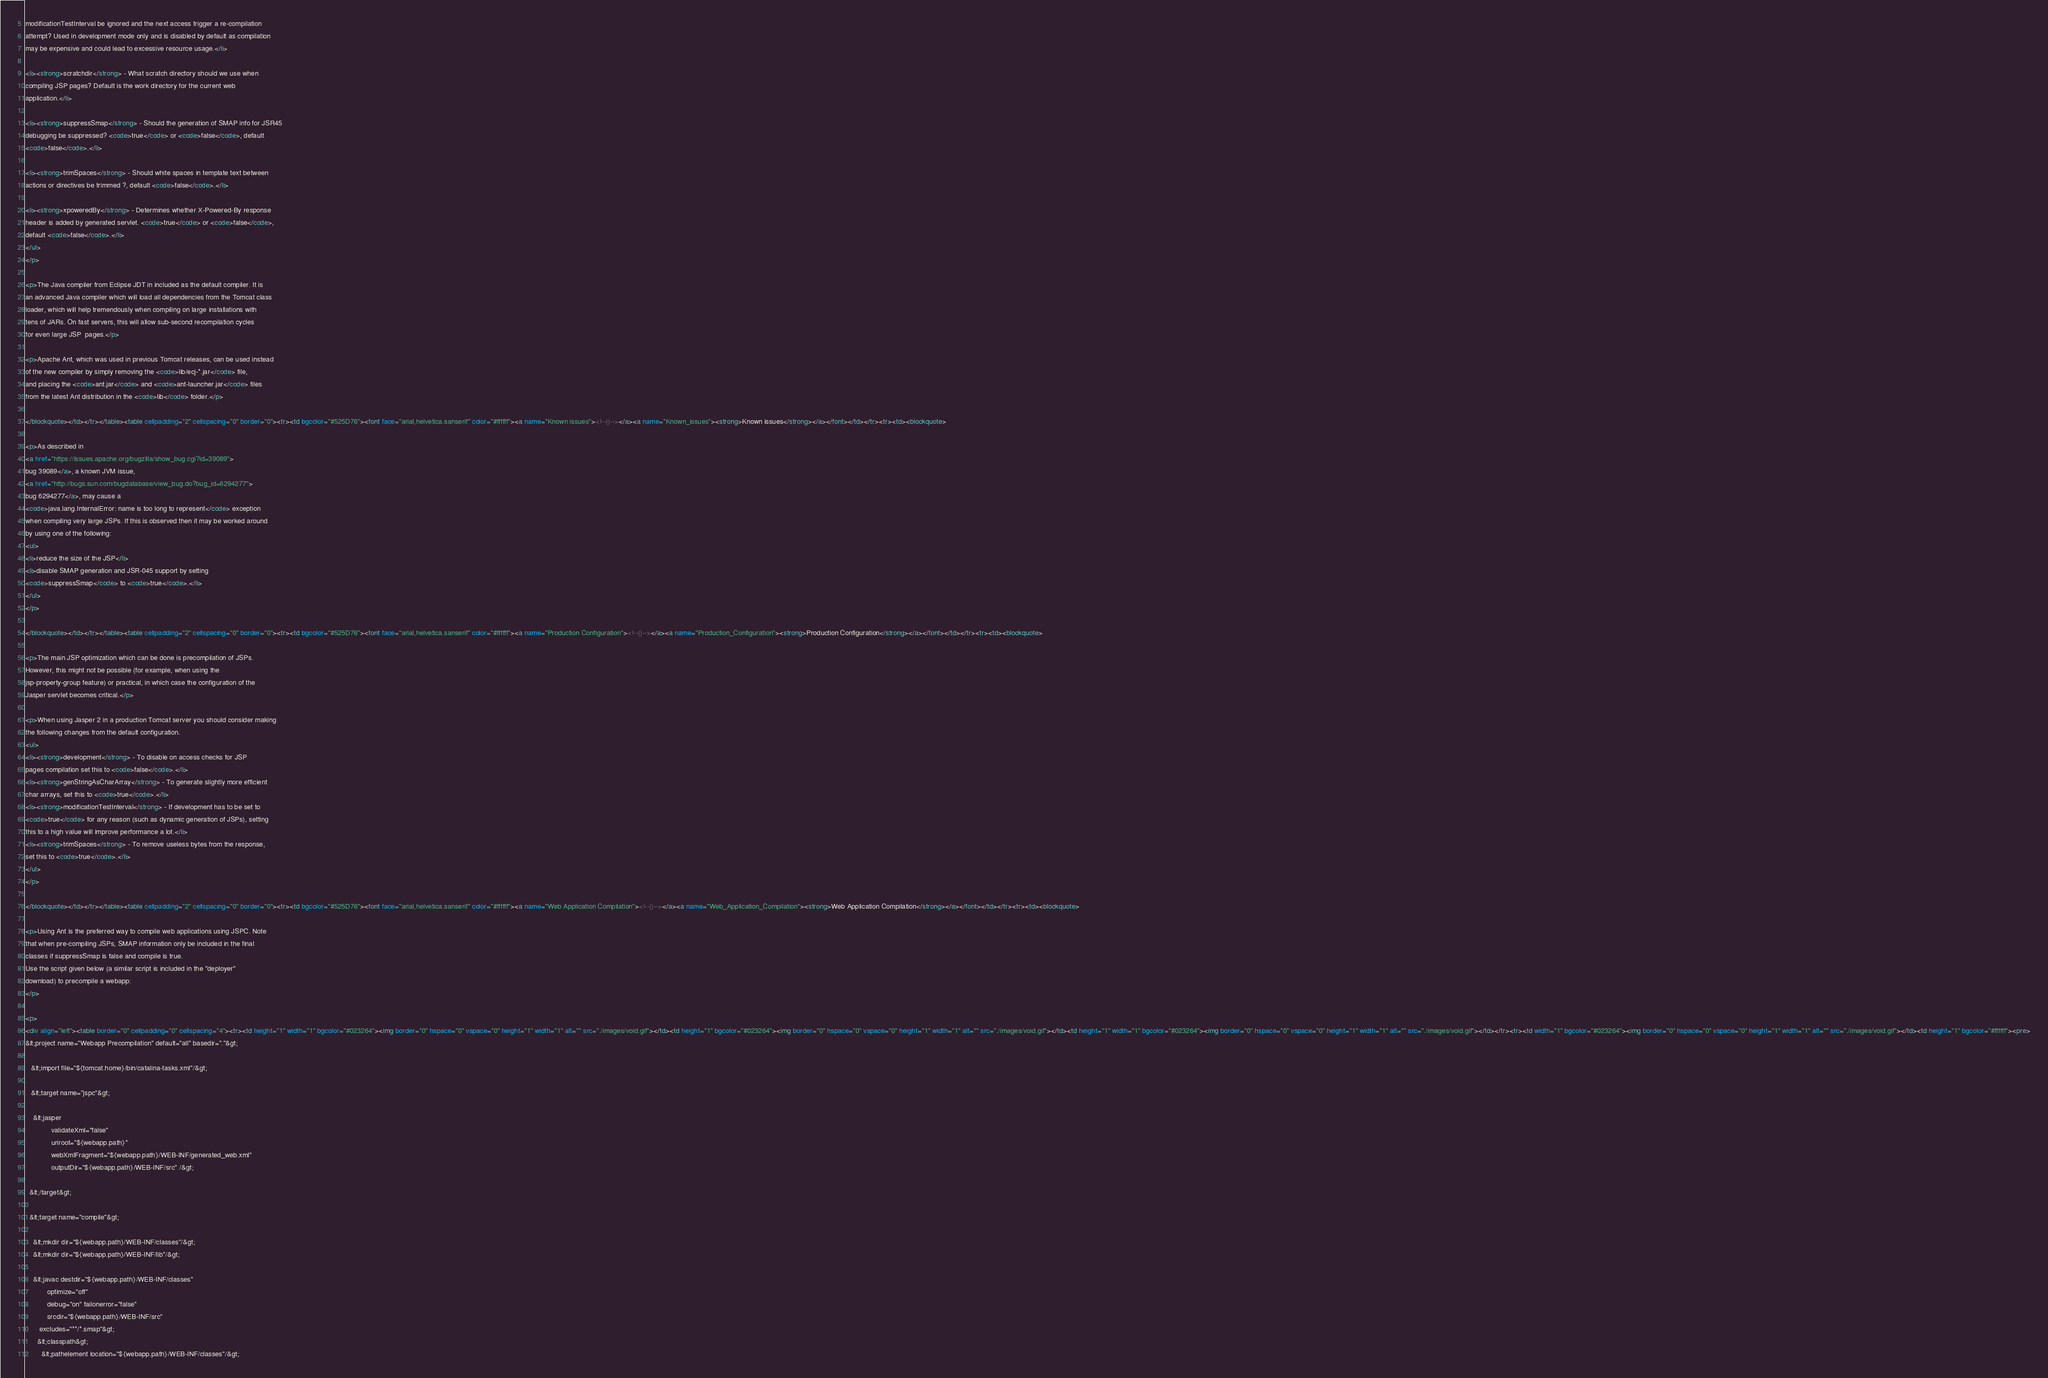<code> <loc_0><loc_0><loc_500><loc_500><_HTML_>modificationTestInterval be ignored and the next access trigger a re-compilation
attempt? Used in development mode only and is disabled by default as compilation
may be expensive and could lead to excessive resource usage.</li>

<li><strong>scratchdir</strong> - What scratch directory should we use when
compiling JSP pages? Default is the work directory for the current web
application.</li>

<li><strong>suppressSmap</strong> - Should the generation of SMAP info for JSR45
debugging be suppressed? <code>true</code> or <code>false</code>, default
<code>false</code>.</li>
 
<li><strong>trimSpaces</strong> - Should white spaces in template text between
actions or directives be trimmed ?, default <code>false</code>.</li>

<li><strong>xpoweredBy</strong> - Determines whether X-Powered-By response
header is added by generated servlet. <code>true</code> or <code>false</code>,
default <code>false</code>.</li>
</ul>
</p>

<p>The Java compiler from Eclipse JDT in included as the default compiler. It is
an advanced Java compiler which will load all dependencies from the Tomcat class
loader, which will help tremendously when compiling on large installations with
tens of JARs. On fast servers, this will allow sub-second recompilation cycles
for even large JSP  pages.</p>

<p>Apache Ant, which was used in previous Tomcat releases, can be used instead
of the new compiler by simply removing the <code>lib/ecj-*.jar</code> file, 
and placing the <code>ant.jar</code> and <code>ant-launcher.jar</code> files
from the latest Ant distribution in the <code>lib</code> folder.</p>

</blockquote></td></tr></table><table cellpadding="2" cellspacing="0" border="0"><tr><td bgcolor="#525D76"><font face="arial,helvetica.sanserif" color="#ffffff"><a name="Known issues"><!--()--></a><a name="Known_issues"><strong>Known issues</strong></a></font></td></tr><tr><td><blockquote>

<p>As described in
<a href="https://issues.apache.org/bugzilla/show_bug.cgi?id=39089">
bug 39089</a>, a known JVM issue,
<a href="http://bugs.sun.com/bugdatabase/view_bug.do?bug_id=6294277">
bug 6294277</a>, may cause a
<code>java.lang.InternalError: name is too long to represent</code> exception
when compiling very large JSPs. If this is observed then it may be worked around
by using one of the following:
<ul>
<li>reduce the size of the JSP</li>
<li>disable SMAP generation and JSR-045 support by setting
<code>suppressSmap</code> to <code>true</code>.</li>
</ul>
</p>

</blockquote></td></tr></table><table cellpadding="2" cellspacing="0" border="0"><tr><td bgcolor="#525D76"><font face="arial,helvetica.sanserif" color="#ffffff"><a name="Production Configuration"><!--()--></a><a name="Production_Configuration"><strong>Production Configuration</strong></a></font></td></tr><tr><td><blockquote>

<p>The main JSP optimization which can be done is precompilation of JSPs.
However, this might not be possible (for example, when using the
jsp-property-group feature) or practical, in which case the configuration of the
Jasper servlet becomes critical.</p>

<p>When using Jasper 2 in a production Tomcat server you should consider making
the following changes from the default configuration.
<ul>
<li><strong>development</strong> - To disable on access checks for JSP
pages compilation set this to <code>false</code>.</li>
<li><strong>genStringAsCharArray</strong> - To generate slightly more efficient 
char arrays, set this to <code>true</code>.</li>
<li><strong>modificationTestInterval</strong> - If development has to be set to
<code>true</code> for any reason (such as dynamic generation of JSPs), setting
this to a high value will improve performance a lot.</li>
<li><strong>trimSpaces</strong> - To remove useless bytes from the response,
set this to <code>true</code>.</li>
</ul>
</p>

</blockquote></td></tr></table><table cellpadding="2" cellspacing="0" border="0"><tr><td bgcolor="#525D76"><font face="arial,helvetica.sanserif" color="#ffffff"><a name="Web Application Compilation"><!--()--></a><a name="Web_Application_Compilation"><strong>Web Application Compilation</strong></a></font></td></tr><tr><td><blockquote>

<p>Using Ant is the preferred way to compile web applications using JSPC. Note
that when pre-compiling JSPs, SMAP information only be included in the final
classes if suppressSmap is false and compile is true. 
Use the script given below (a similar script is included in the "deployer" 
download) to precompile a webapp:
</p>

<p>
<div align="left"><table border="0" cellpadding="0" cellspacing="4"><tr><td height="1" width="1" bgcolor="#023264"><img border="0" hspace="0" vspace="0" height="1" width="1" alt="" src="./images/void.gif"></td><td height="1" bgcolor="#023264"><img border="0" hspace="0" vspace="0" height="1" width="1" alt="" src="./images/void.gif"></td><td height="1" width="1" bgcolor="#023264"><img border="0" hspace="0" vspace="0" height="1" width="1" alt="" src="./images/void.gif"></td></tr><tr><td width="1" bgcolor="#023264"><img border="0" hspace="0" vspace="0" height="1" width="1" alt="" src="./images/void.gif"></td><td height="1" bgcolor="#ffffff"><pre>
&lt;project name="Webapp Precompilation" default="all" basedir="."&gt; 

   &lt;import file="${tomcat.home}/bin/catalina-tasks.xml"/&gt;
  
   &lt;target name="jspc"&gt; 

    &lt;jasper 
             validateXml="false" 
             uriroot="${webapp.path}" 
             webXmlFragment="${webapp.path}/WEB-INF/generated_web.xml" 
             outputDir="${webapp.path}/WEB-INF/src" /&gt; 

  &lt;/target&gt; 

  &lt;target name="compile"&gt;

    &lt;mkdir dir="${webapp.path}/WEB-INF/classes"/&gt;
    &lt;mkdir dir="${webapp.path}/WEB-INF/lib"/&gt;

    &lt;javac destdir="${webapp.path}/WEB-INF/classes"
           optimize="off"
           debug="on" failonerror="false"
           srcdir="${webapp.path}/WEB-INF/src" 
	   excludes="**/*.smap"&gt;
      &lt;classpath&gt;
        &lt;pathelement location="${webapp.path}/WEB-INF/classes"/&gt;</code> 